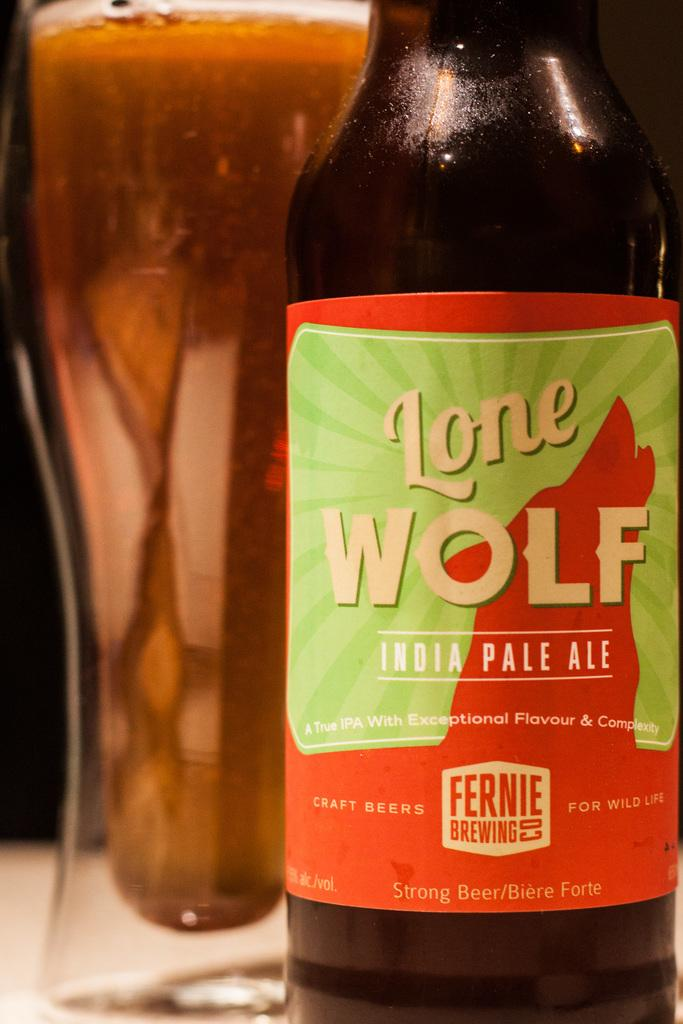Provide a one-sentence caption for the provided image. An Indian pale ale called Lone Wolf on a table. 